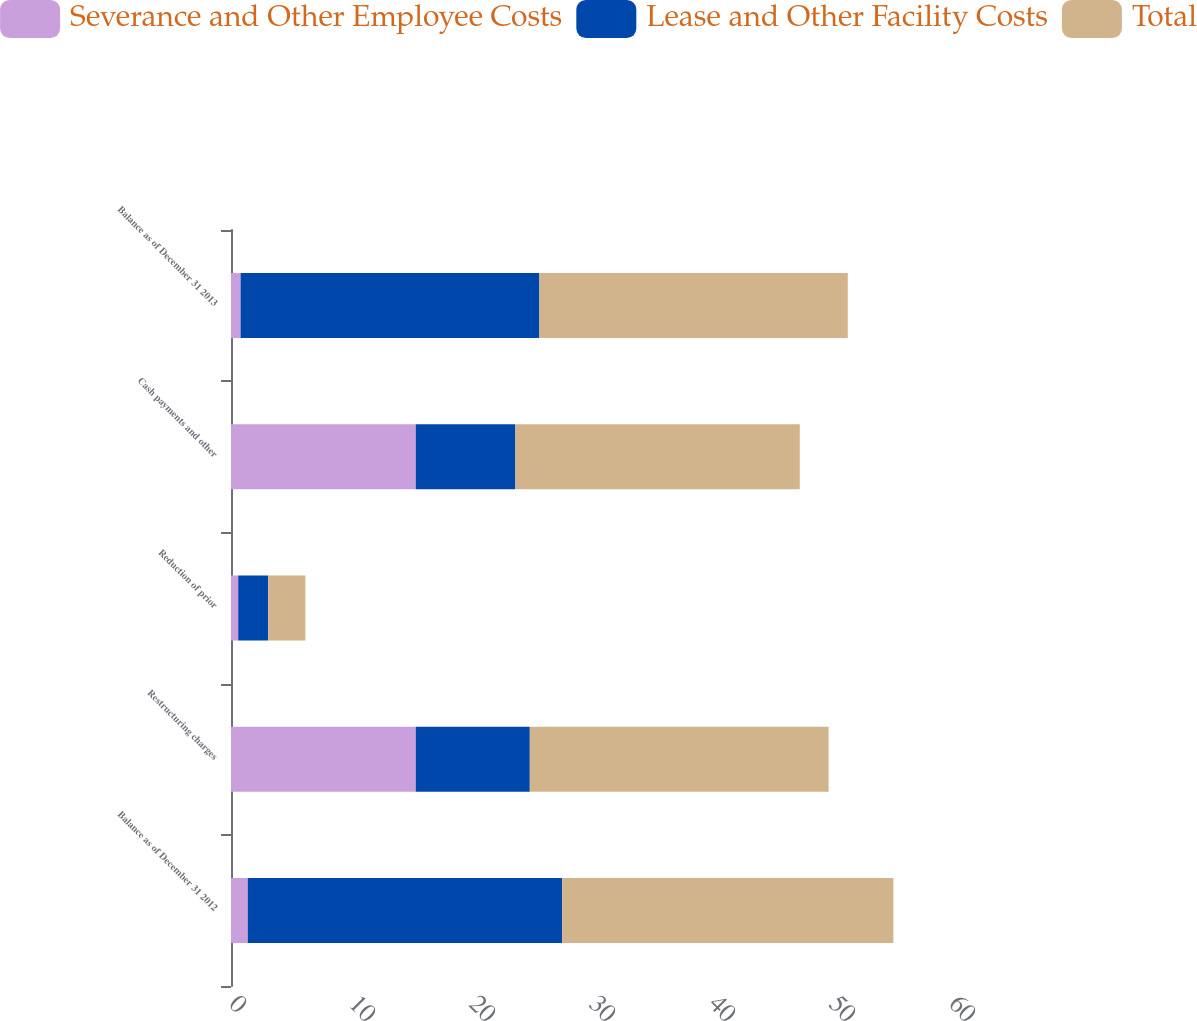<chart> <loc_0><loc_0><loc_500><loc_500><stacked_bar_chart><ecel><fcel>Balance as of December 31 2012<fcel>Restructuring charges<fcel>Reduction of prior<fcel>Cash payments and other<fcel>Balance as of December 31 2013<nl><fcel>Severance and Other Employee Costs<fcel>1.4<fcel>15.4<fcel>0.6<fcel>15.4<fcel>0.8<nl><fcel>Lease and Other Facility Costs<fcel>26.2<fcel>9.5<fcel>2.5<fcel>8.3<fcel>24.9<nl><fcel>Total<fcel>27.6<fcel>24.9<fcel>3.1<fcel>23.7<fcel>25.7<nl></chart> 